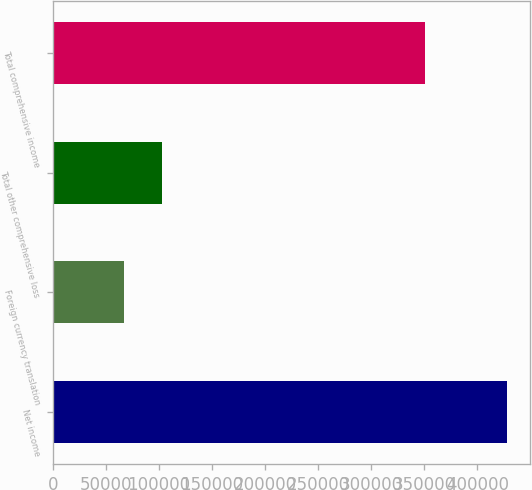<chart> <loc_0><loc_0><loc_500><loc_500><bar_chart><fcel>Net income<fcel>Foreign currency translation<fcel>Total other comprehensive loss<fcel>Total comprehensive income<nl><fcel>428451<fcel>67269<fcel>103387<fcel>350286<nl></chart> 